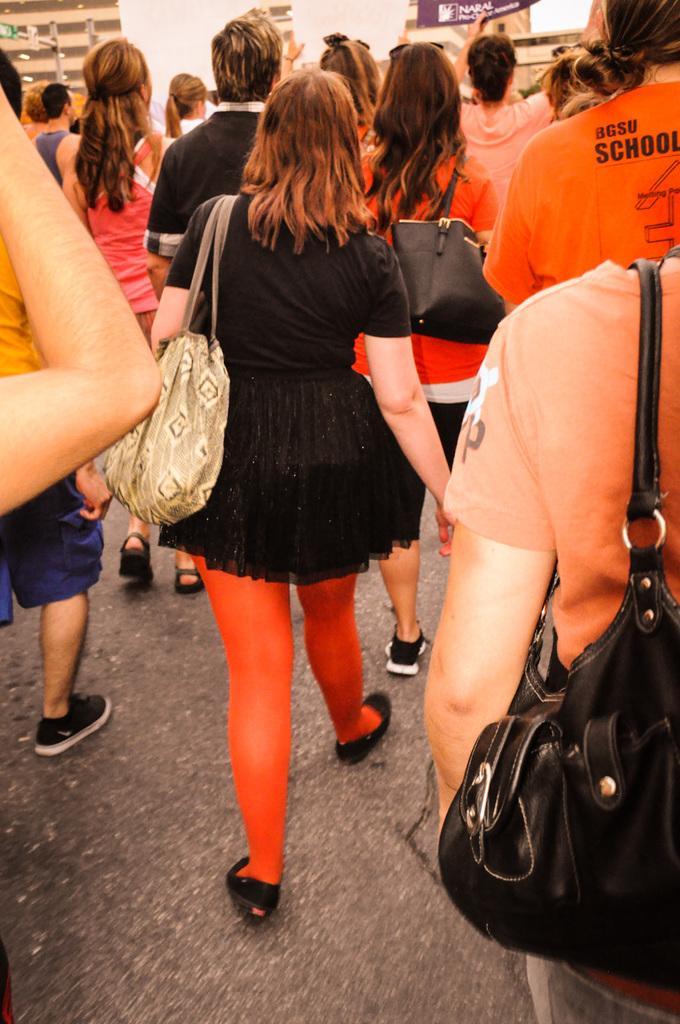Could you give a brief overview of what you see in this image? In the image there are group of people. In middle there is a woman wearing a black color top and cream color handbag walking on road. In background we can see some buildings,pole,hoardings. 